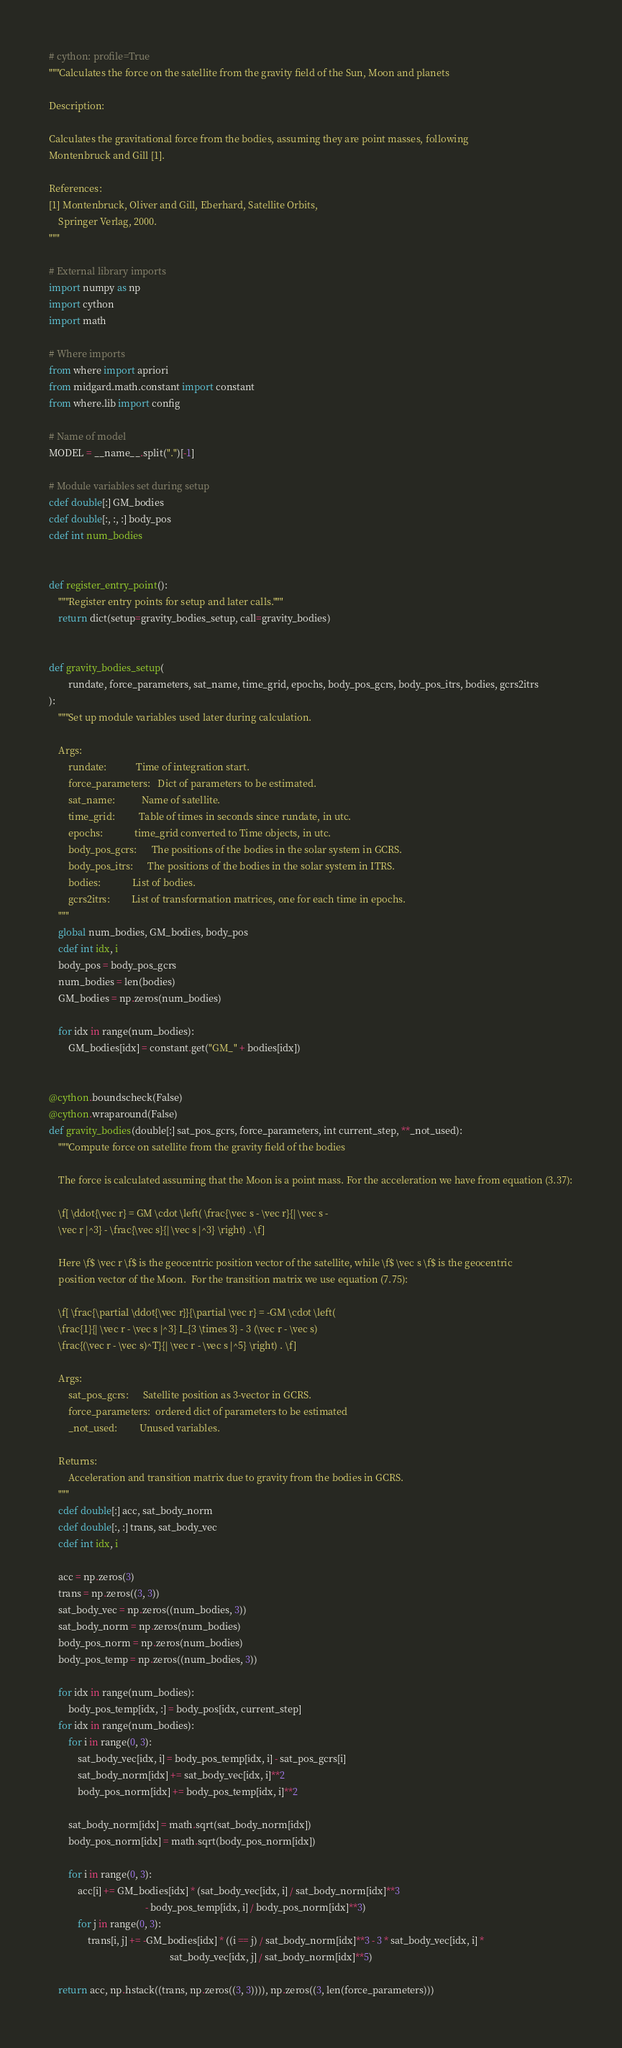Convert code to text. <code><loc_0><loc_0><loc_500><loc_500><_Cython_># cython: profile=True
"""Calculates the force on the satellite from the gravity field of the Sun, Moon and planets

Description:

Calculates the gravitational force from the bodies, assuming they are point masses, following
Montenbruck and Gill [1].

References:
[1] Montenbruck, Oliver and Gill, Eberhard, Satellite Orbits,
    Springer Verlag, 2000.
"""

# External library imports
import numpy as np
import cython
import math

# Where imports
from where import apriori
from midgard.math.constant import constant
from where.lib import config

# Name of model
MODEL = __name__.split(".")[-1]

# Module variables set during setup
cdef double[:] GM_bodies
cdef double[:, :, :] body_pos
cdef int num_bodies


def register_entry_point():
    """Register entry points for setup and later calls."""
    return dict(setup=gravity_bodies_setup, call=gravity_bodies)


def gravity_bodies_setup(
        rundate, force_parameters, sat_name, time_grid, epochs, body_pos_gcrs, body_pos_itrs, bodies, gcrs2itrs
):
    """Set up module variables used later during calculation.

    Args:
        rundate:            Time of integration start.
        force_parameters:   Dict of parameters to be estimated.
        sat_name:           Name of satellite.
        time_grid:          Table of times in seconds since rundate, in utc.
        epochs:             time_grid converted to Time objects, in utc.
        body_pos_gcrs:      The positions of the bodies in the solar system in GCRS.
        body_pos_itrs:      The positions of the bodies in the solar system in ITRS.
        bodies:             List of bodies.
        gcrs2itrs:         List of transformation matrices, one for each time in epochs.
    """
    global num_bodies, GM_bodies, body_pos
    cdef int idx, i
    body_pos = body_pos_gcrs
    num_bodies = len(bodies)
    GM_bodies = np.zeros(num_bodies)

    for idx in range(num_bodies):
        GM_bodies[idx] = constant.get("GM_" + bodies[idx])


@cython.boundscheck(False)
@cython.wraparound(False)
def gravity_bodies(double[:] sat_pos_gcrs, force_parameters, int current_step, **_not_used):
    """Compute force on satellite from the gravity field of the bodies

    The force is calculated assuming that the Moon is a point mass. For the acceleration we have from equation (3.37):

    \f[ \ddot{\vec r} = GM \cdot \left( \frac{\vec s - \vec r}{| \vec s -
    \vec r |^3} - \frac{\vec s}{| \vec s |^3} \right) . \f]

    Here \f$ \vec r \f$ is the geocentric position vector of the satellite, while \f$ \vec s \f$ is the geocentric
    position vector of the Moon.  For the transition matrix we use equation (7.75):

    \f[ \frac{\partial \ddot{\vec r}}{\partial \vec r} = -GM \cdot \left(
    \frac{1}{| \vec r - \vec s |^3} I_{3 \times 3} - 3 (\vec r - \vec s)
    \frac{(\vec r - \vec s)^T}{| \vec r - \vec s |^5} \right) . \f]

    Args:
        sat_pos_gcrs:      Satellite position as 3-vector in GCRS.
        force_parameters:  ordered dict of parameters to be estimated
        _not_used:         Unused variables.

    Returns:
        Acceleration and transition matrix due to gravity from the bodies in GCRS.
    """
    cdef double[:] acc, sat_body_norm
    cdef double[:, :] trans, sat_body_vec
    cdef int idx, i

    acc = np.zeros(3)
    trans = np.zeros((3, 3))
    sat_body_vec = np.zeros((num_bodies, 3))
    sat_body_norm = np.zeros(num_bodies)
    body_pos_norm = np.zeros(num_bodies)
    body_pos_temp = np.zeros((num_bodies, 3))

    for idx in range(num_bodies):
        body_pos_temp[idx, :] = body_pos[idx, current_step]
    for idx in range(num_bodies):
        for i in range(0, 3):
            sat_body_vec[idx, i] = body_pos_temp[idx, i] - sat_pos_gcrs[i]
            sat_body_norm[idx] += sat_body_vec[idx, i]**2
            body_pos_norm[idx] += body_pos_temp[idx, i]**2

        sat_body_norm[idx] = math.sqrt(sat_body_norm[idx])
        body_pos_norm[idx] = math.sqrt(body_pos_norm[idx])

        for i in range(0, 3):
            acc[i] += GM_bodies[idx] * (sat_body_vec[idx, i] / sat_body_norm[idx]**3
                                        - body_pos_temp[idx, i] / body_pos_norm[idx]**3)
            for j in range(0, 3):
                trans[i, j] += -GM_bodies[idx] * ((i == j) / sat_body_norm[idx]**3 - 3 * sat_body_vec[idx, i] *
                                                  sat_body_vec[idx, j] / sat_body_norm[idx]**5)

    return acc, np.hstack((trans, np.zeros((3, 3)))), np.zeros((3, len(force_parameters)))
</code> 